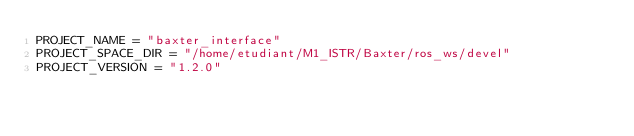<code> <loc_0><loc_0><loc_500><loc_500><_Python_>PROJECT_NAME = "baxter_interface"
PROJECT_SPACE_DIR = "/home/etudiant/M1_ISTR/Baxter/ros_ws/devel"
PROJECT_VERSION = "1.2.0"
</code> 